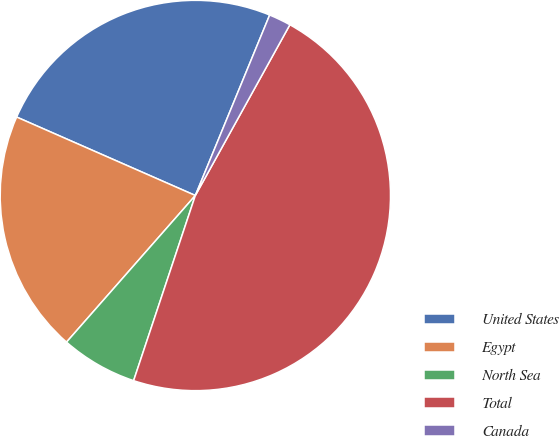Convert chart to OTSL. <chart><loc_0><loc_0><loc_500><loc_500><pie_chart><fcel>United States<fcel>Egypt<fcel>North Sea<fcel>Total<fcel>Canada<nl><fcel>24.63%<fcel>20.11%<fcel>6.35%<fcel>47.07%<fcel>1.83%<nl></chart> 